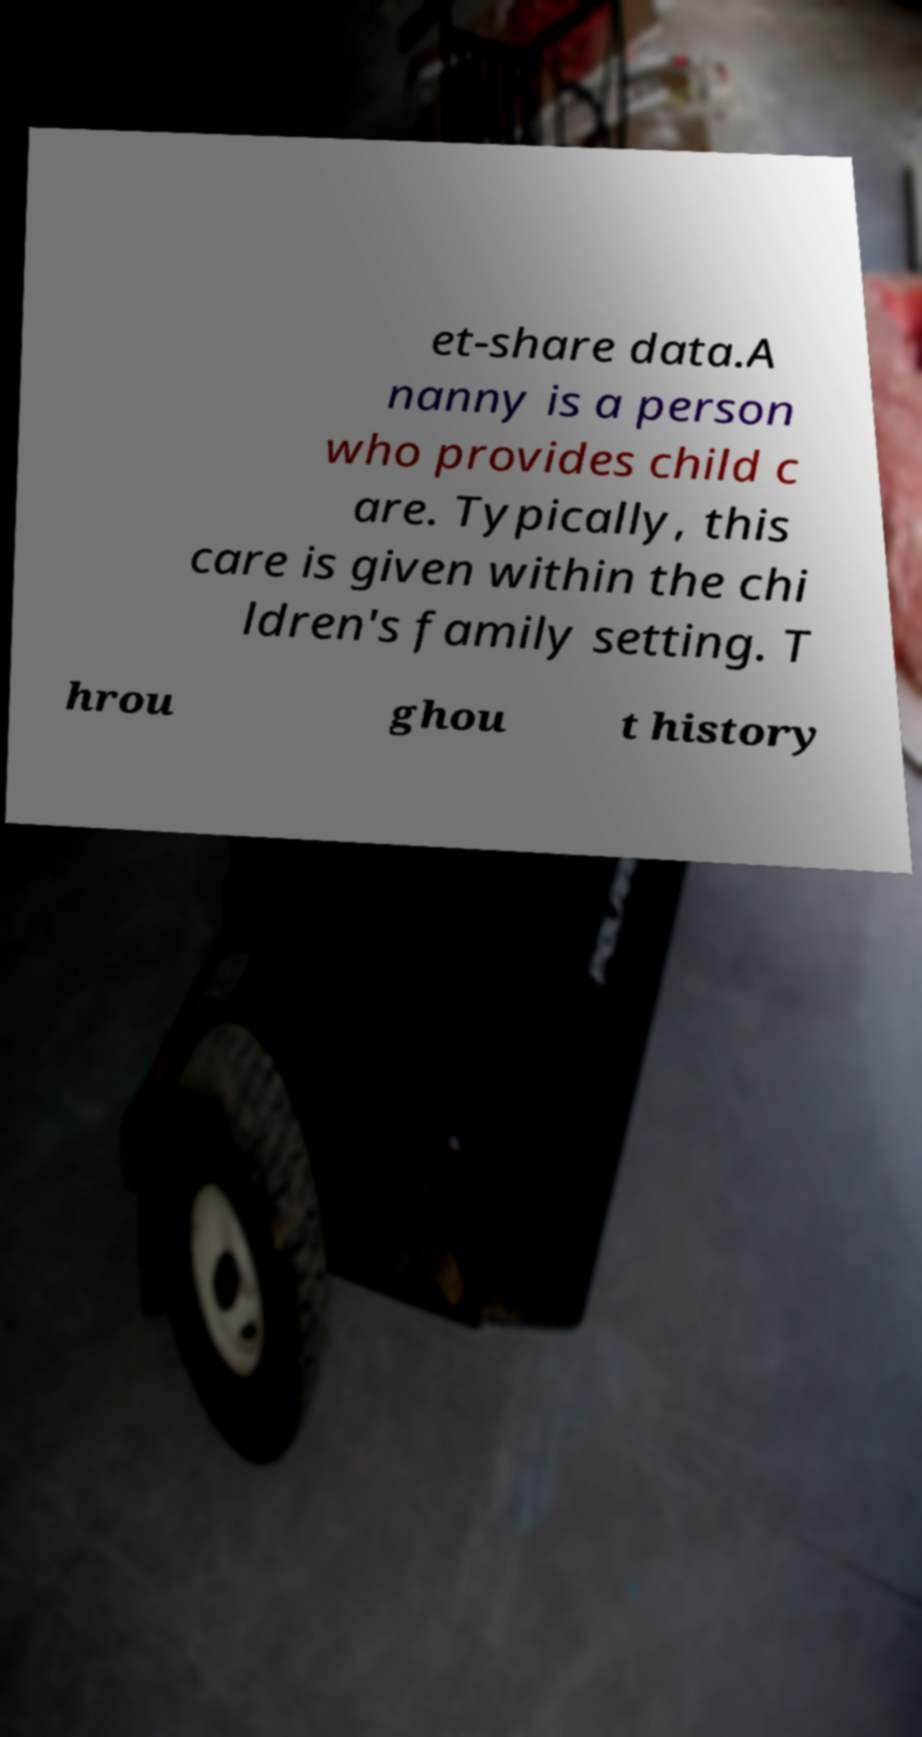What messages or text are displayed in this image? I need them in a readable, typed format. et-share data.A nanny is a person who provides child c are. Typically, this care is given within the chi ldren's family setting. T hrou ghou t history 